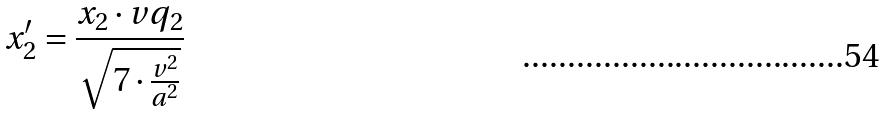Convert formula to latex. <formula><loc_0><loc_0><loc_500><loc_500>x _ { 2 } ^ { \prime } = \frac { x _ { 2 } \cdot v q _ { 2 } } { \sqrt { 7 \cdot \frac { v ^ { 2 } } { a ^ { 2 } } } }</formula> 